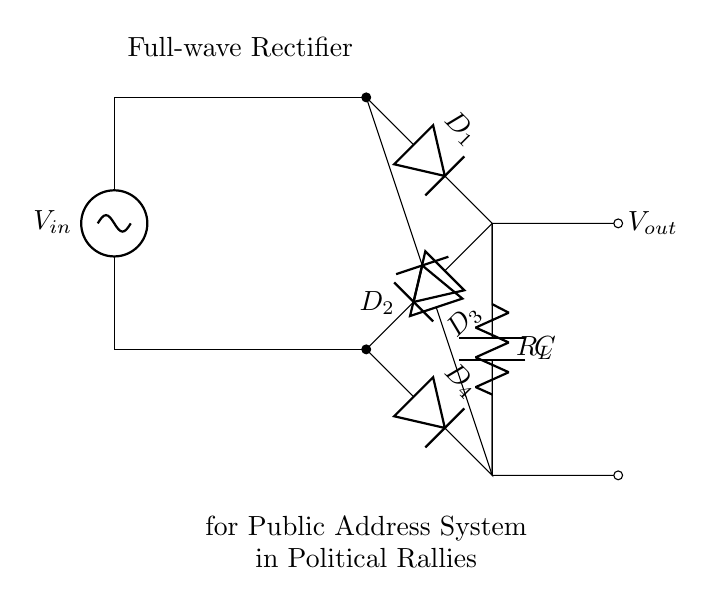what is the main purpose of the circuit? The circuit is designed to convert AC voltage to DC voltage. This is evidenced by the presence of a full-wave rectifier, which is intended to provide a steady output voltage for powering devices in a public address system.
Answer: converting AC to DC how many diodes are used in this full-wave rectifier? The circuit displays a total of four diodes. This can be confirmed by counting the diode symbols labeled as D1, D2, D3, and D4 in the bridge rectifier configuration.
Answer: four what type of component is used to store energy in this circuit? The component used for energy storage in this circuit is a capacitor, labeled as C. This is verified by identifying the symbol and its function within the circuit, which is to smooth the DC output.
Answer: capacitor what is the expected output voltage type of this rectifier circuit? The expected output voltage type from this rectifier circuit is DC voltage since full-wave rectification converts the AC input into a pulsating direct current, typically used in electronic devices.
Answer: DC voltage why is a transformer included in this circuit? The transformer is included to step up or step down the AC voltage before it is rectified. This is necessary to ensure the input voltage is at an appropriate level for the rectifier and the overall design of the public address system.
Answer: to adjust AC voltage 